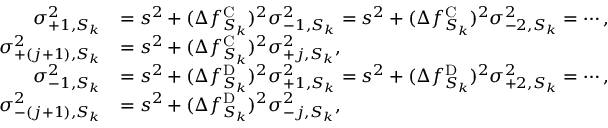<formula> <loc_0><loc_0><loc_500><loc_500>\begin{array} { r l } { \sigma _ { + 1 , S _ { k } } ^ { 2 } } & { = s ^ { 2 } + ( \Delta f _ { S _ { k } } ^ { C } ) ^ { 2 } \sigma _ { - 1 , S _ { k } } ^ { 2 } = s ^ { 2 } + ( \Delta f _ { S _ { k } } ^ { C } ) ^ { 2 } \sigma _ { - 2 , S _ { k } } ^ { 2 } = \cdots , } \\ { \sigma _ { + ( j + 1 ) , S _ { k } } ^ { 2 } } & { = s ^ { 2 } + ( \Delta f _ { S _ { k } } ^ { C } ) ^ { 2 } \sigma _ { + j , S _ { k } } ^ { 2 } , } \\ { \sigma _ { - 1 , S _ { k } } ^ { 2 } } & { = s ^ { 2 } + ( \Delta f _ { S _ { k } } ^ { D } ) ^ { 2 } \sigma _ { + 1 , S _ { k } } ^ { 2 } = s ^ { 2 } + ( \Delta f _ { S _ { k } } ^ { D } ) ^ { 2 } \sigma _ { + 2 , S _ { k } } ^ { 2 } = \cdots , } \\ { \sigma _ { - ( j + 1 ) , S _ { k } } ^ { 2 } } & { = s ^ { 2 } + ( \Delta f _ { S _ { k } } ^ { D } ) ^ { 2 } \sigma _ { - j , S _ { k } } ^ { 2 } , } \end{array}</formula> 